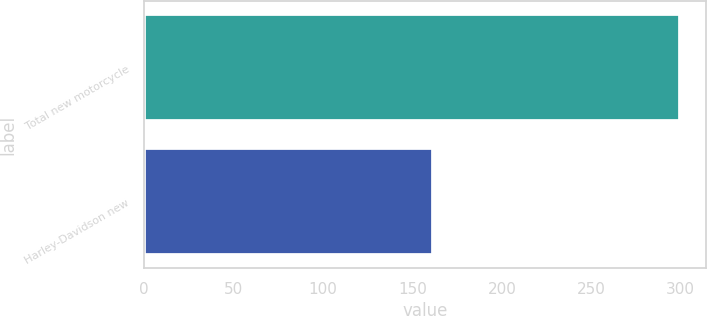Convert chart to OTSL. <chart><loc_0><loc_0><loc_500><loc_500><bar_chart><fcel>Total new motorcycle<fcel>Harley-Davidson new<nl><fcel>299.4<fcel>161.3<nl></chart> 